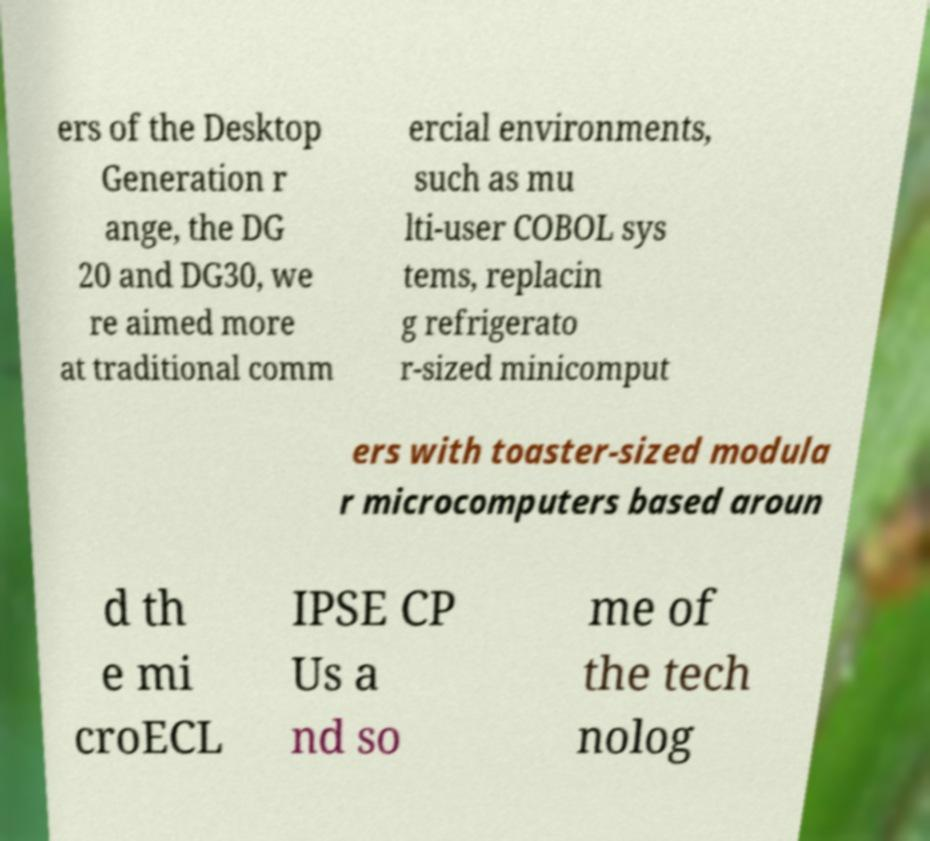Please read and relay the text visible in this image. What does it say? ers of the Desktop Generation r ange, the DG 20 and DG30, we re aimed more at traditional comm ercial environments, such as mu lti-user COBOL sys tems, replacin g refrigerato r-sized minicomput ers with toaster-sized modula r microcomputers based aroun d th e mi croECL IPSE CP Us a nd so me of the tech nolog 